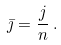<formula> <loc_0><loc_0><loc_500><loc_500>\bar { \jmath } = \frac { j } { n } \, .</formula> 